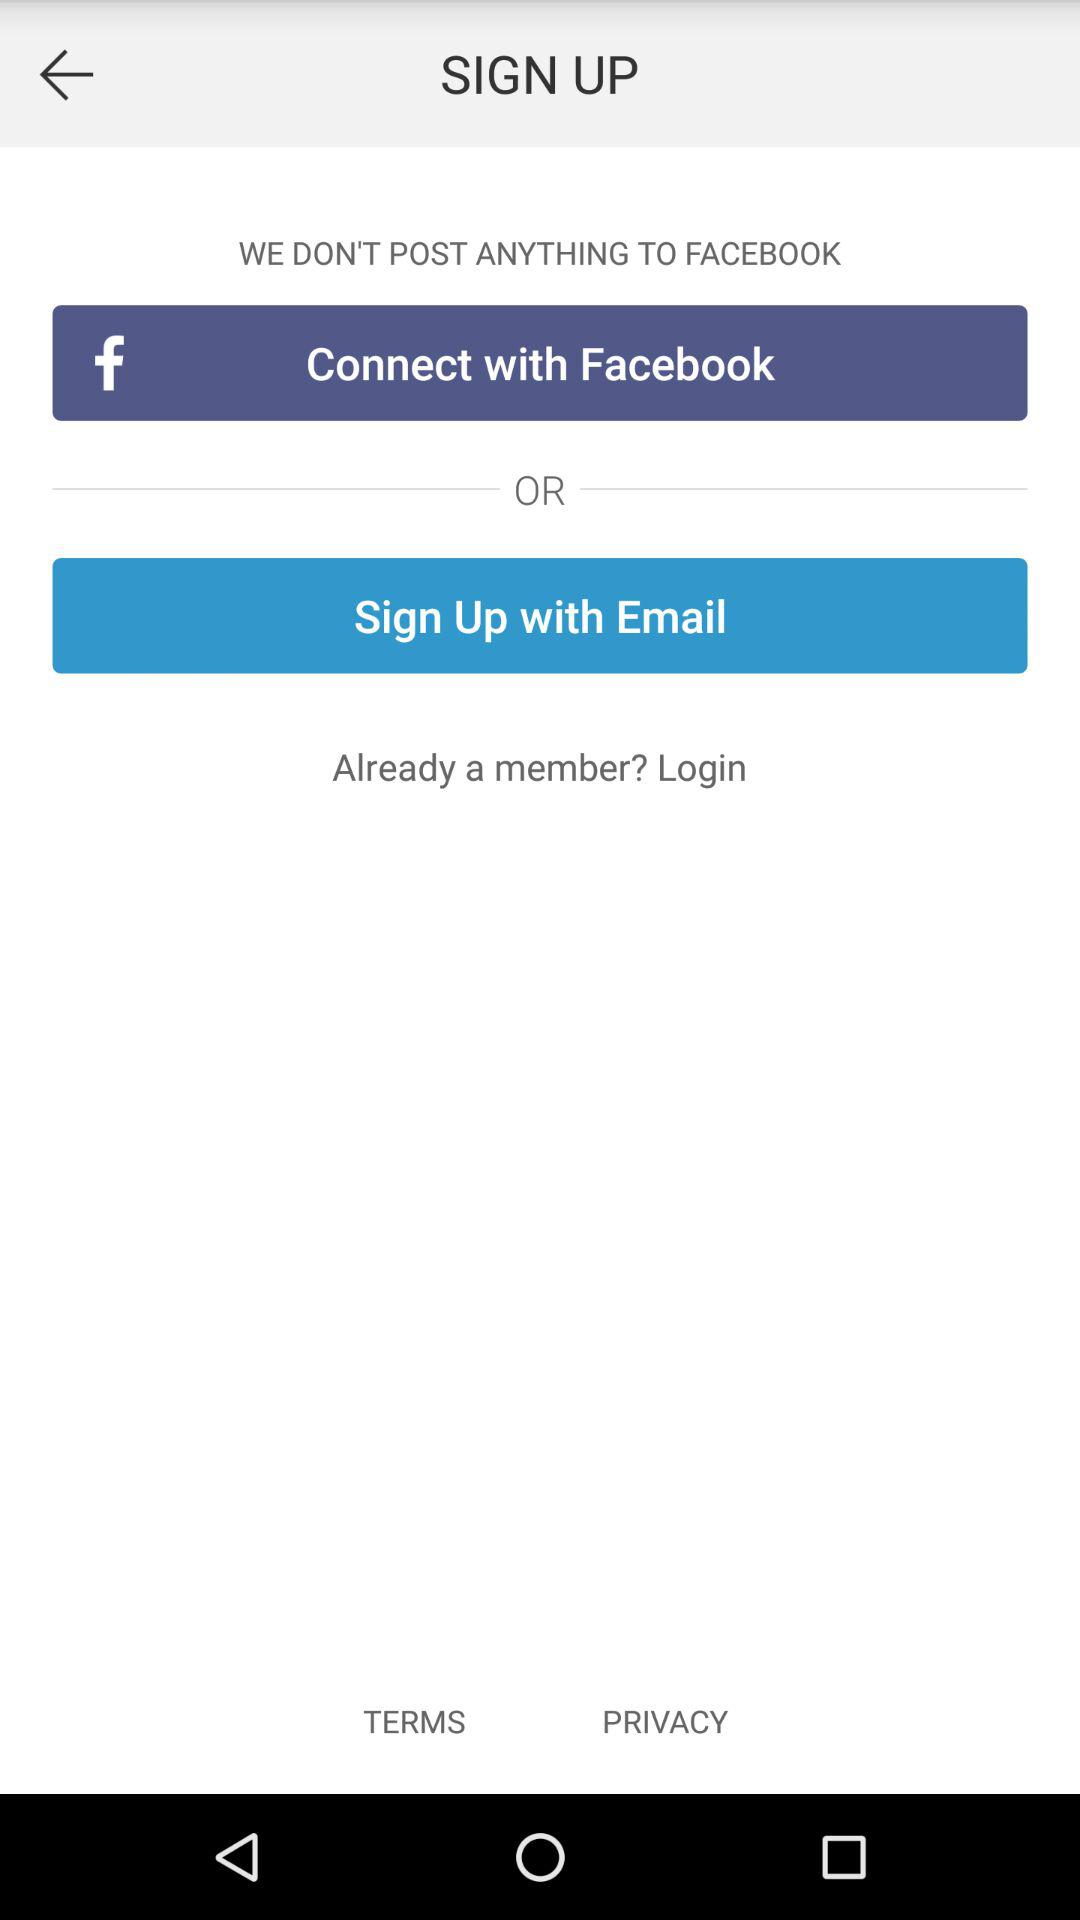What accounts can I use to sign up? You can sign up with "Connect with Facebook" and "Sign Up with Email". 